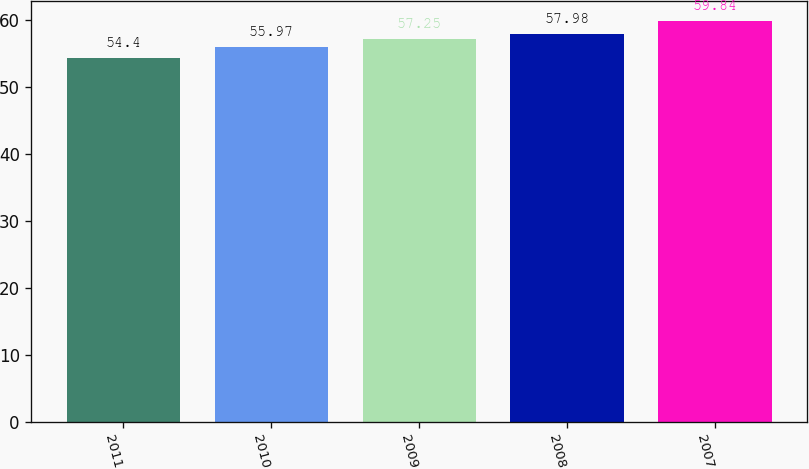<chart> <loc_0><loc_0><loc_500><loc_500><bar_chart><fcel>2011<fcel>2010<fcel>2009<fcel>2008<fcel>2007<nl><fcel>54.4<fcel>55.97<fcel>57.25<fcel>57.98<fcel>59.84<nl></chart> 